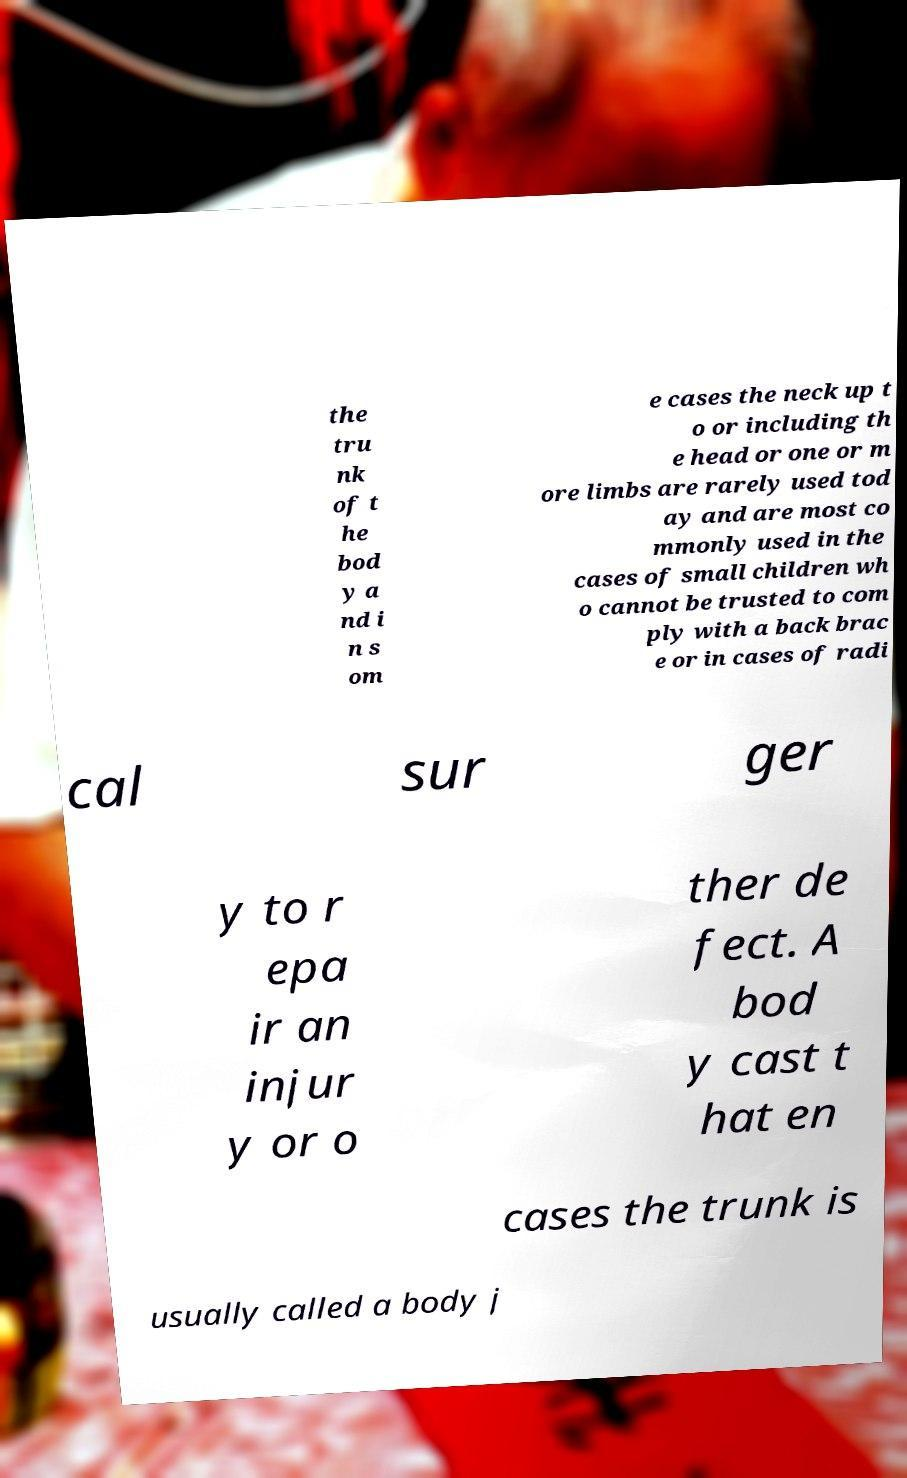Can you read and provide the text displayed in the image?This photo seems to have some interesting text. Can you extract and type it out for me? the tru nk of t he bod y a nd i n s om e cases the neck up t o or including th e head or one or m ore limbs are rarely used tod ay and are most co mmonly used in the cases of small children wh o cannot be trusted to com ply with a back brac e or in cases of radi cal sur ger y to r epa ir an injur y or o ther de fect. A bod y cast t hat en cases the trunk is usually called a body j 